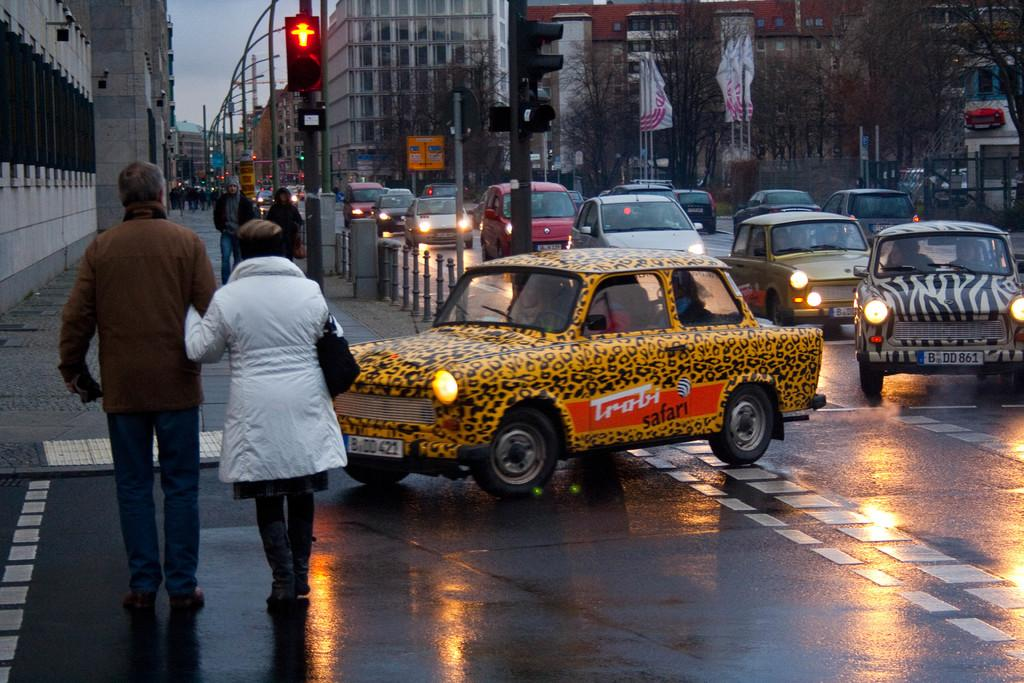Provide a one-sentence caption for the provided image. A cheetah print car with the words Trobi Safari written on the door drives down a rainy street. 